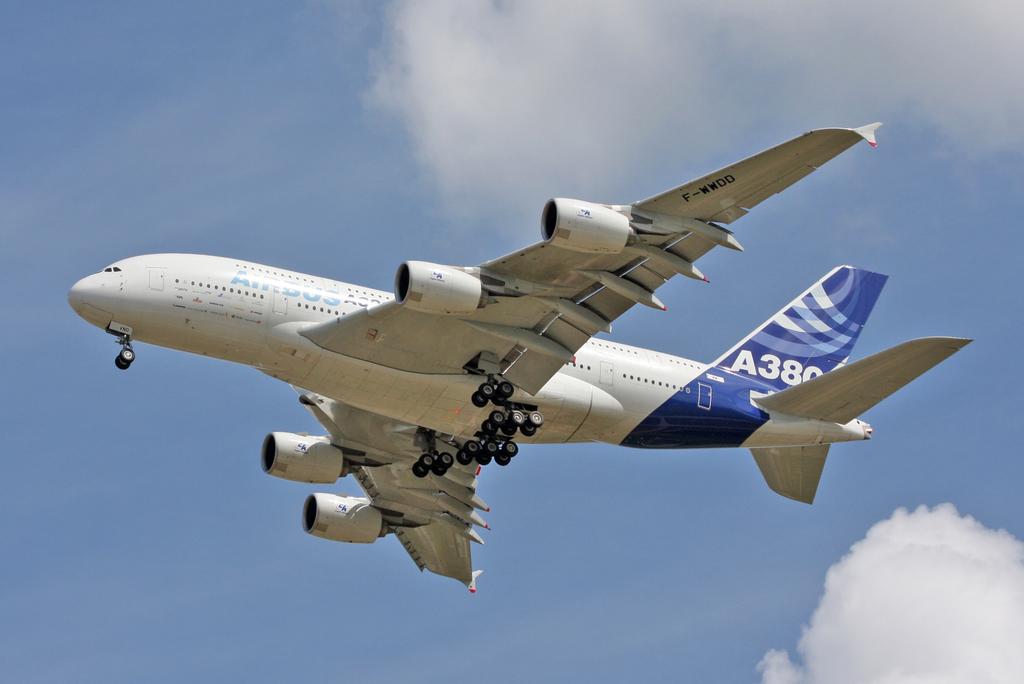What number is on the underside of the wing?
Keep it short and to the point. F-wwdd. What number is the plane?
Keep it short and to the point. A380. 